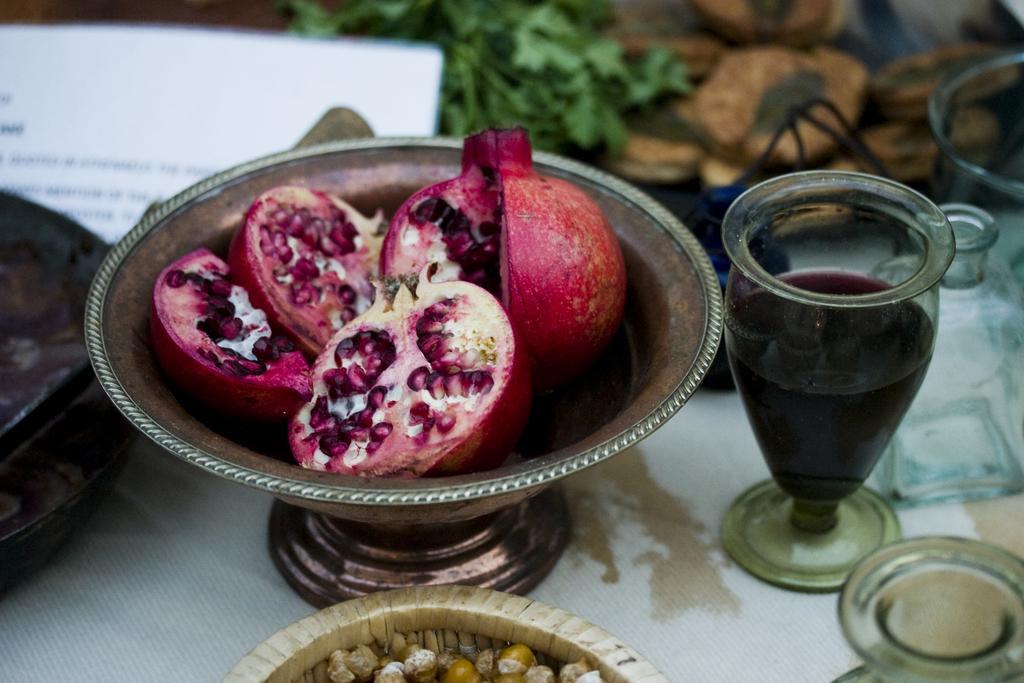Please provide a concise description of this image. In this image we can see some pomegranates which are cut into pieces are placed in a bowl, there is some drink in a glass, there are some glasses, paper, leaves and some other items on table. 